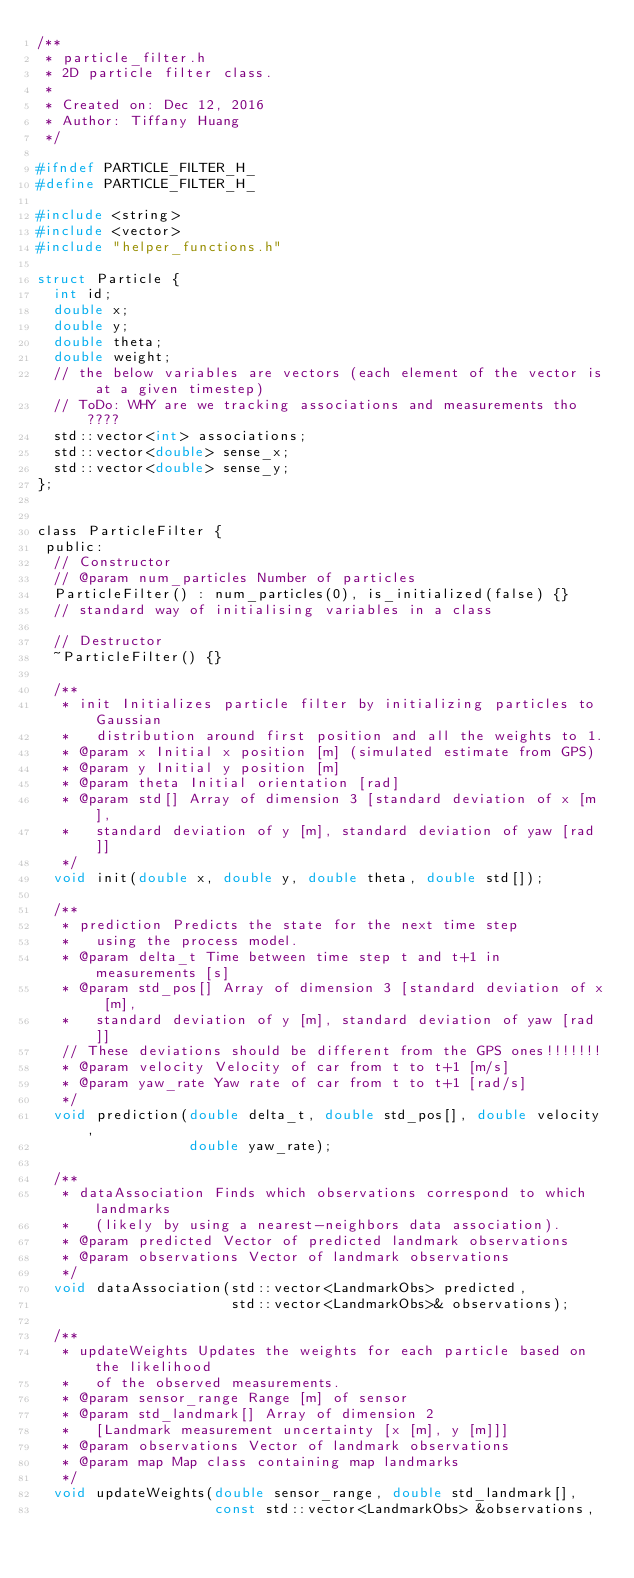<code> <loc_0><loc_0><loc_500><loc_500><_C_>/**
 * particle_filter.h
 * 2D particle filter class.
 *
 * Created on: Dec 12, 2016
 * Author: Tiffany Huang
 */

#ifndef PARTICLE_FILTER_H_
#define PARTICLE_FILTER_H_

#include <string>
#include <vector>
#include "helper_functions.h"

struct Particle {
  int id;
  double x;
  double y;
  double theta;
  double weight;
  // the below variables are vectors (each element of the vector is at a given timestep)
  // ToDo: WHY are we tracking associations and measurements tho????
  std::vector<int> associations; 
  std::vector<double> sense_x;
  std::vector<double> sense_y;
};


class ParticleFilter {  
 public:
  // Constructor
  // @param num_particles Number of particles
  ParticleFilter() : num_particles(0), is_initialized(false) {}
  // standard way of initialising variables in a class

  // Destructor
  ~ParticleFilter() {}

  /**
   * init Initializes particle filter by initializing particles to Gaussian
   *   distribution around first position and all the weights to 1.
   * @param x Initial x position [m] (simulated estimate from GPS)
   * @param y Initial y position [m]
   * @param theta Initial orientation [rad]
   * @param std[] Array of dimension 3 [standard deviation of x [m], 
   *   standard deviation of y [m], standard deviation of yaw [rad]]
   */
  void init(double x, double y, double theta, double std[]);

  /**
   * prediction Predicts the state for the next time step
   *   using the process model.
   * @param delta_t Time between time step t and t+1 in measurements [s]
   * @param std_pos[] Array of dimension 3 [standard deviation of x [m], 
   *   standard deviation of y [m], standard deviation of yaw [rad]]
   // These deviations should be different from the GPS ones!!!!!!!
   * @param velocity Velocity of car from t to t+1 [m/s]
   * @param yaw_rate Yaw rate of car from t to t+1 [rad/s]
   */
  void prediction(double delta_t, double std_pos[], double velocity, 
                  double yaw_rate);
  
  /**
   * dataAssociation Finds which observations correspond to which landmarks 
   *   (likely by using a nearest-neighbors data association).
   * @param predicted Vector of predicted landmark observations
   * @param observations Vector of landmark observations
   */
  void dataAssociation(std::vector<LandmarkObs> predicted, 
                       std::vector<LandmarkObs>& observations);
  
  /**
   * updateWeights Updates the weights for each particle based on the likelihood
   *   of the observed measurements. 
   * @param sensor_range Range [m] of sensor
   * @param std_landmark[] Array of dimension 2
   *   [Landmark measurement uncertainty [x [m], y [m]]]
   * @param observations Vector of landmark observations
   * @param map Map class containing map landmarks
   */
  void updateWeights(double sensor_range, double std_landmark[], 
                     const std::vector<LandmarkObs> &observations,</code> 